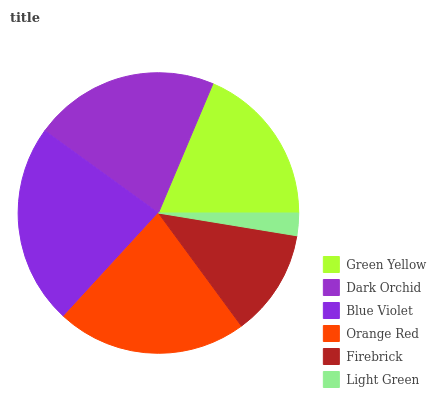Is Light Green the minimum?
Answer yes or no. Yes. Is Blue Violet the maximum?
Answer yes or no. Yes. Is Dark Orchid the minimum?
Answer yes or no. No. Is Dark Orchid the maximum?
Answer yes or no. No. Is Dark Orchid greater than Green Yellow?
Answer yes or no. Yes. Is Green Yellow less than Dark Orchid?
Answer yes or no. Yes. Is Green Yellow greater than Dark Orchid?
Answer yes or no. No. Is Dark Orchid less than Green Yellow?
Answer yes or no. No. Is Dark Orchid the high median?
Answer yes or no. Yes. Is Green Yellow the low median?
Answer yes or no. Yes. Is Blue Violet the high median?
Answer yes or no. No. Is Orange Red the low median?
Answer yes or no. No. 